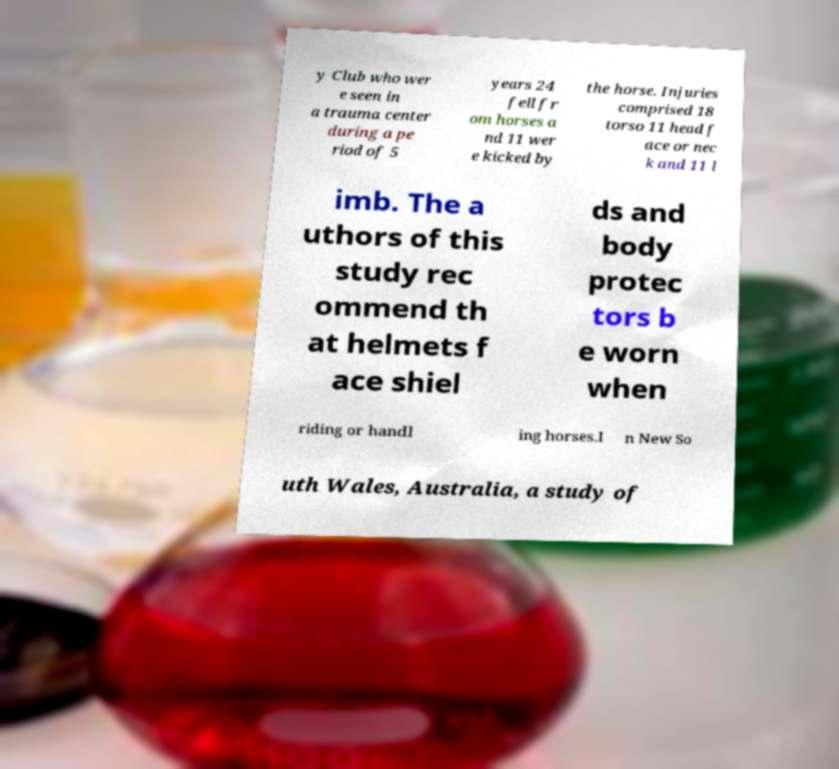Can you accurately transcribe the text from the provided image for me? y Club who wer e seen in a trauma center during a pe riod of 5 years 24 fell fr om horses a nd 11 wer e kicked by the horse. Injuries comprised 18 torso 11 head f ace or nec k and 11 l imb. The a uthors of this study rec ommend th at helmets f ace shiel ds and body protec tors b e worn when riding or handl ing horses.I n New So uth Wales, Australia, a study of 